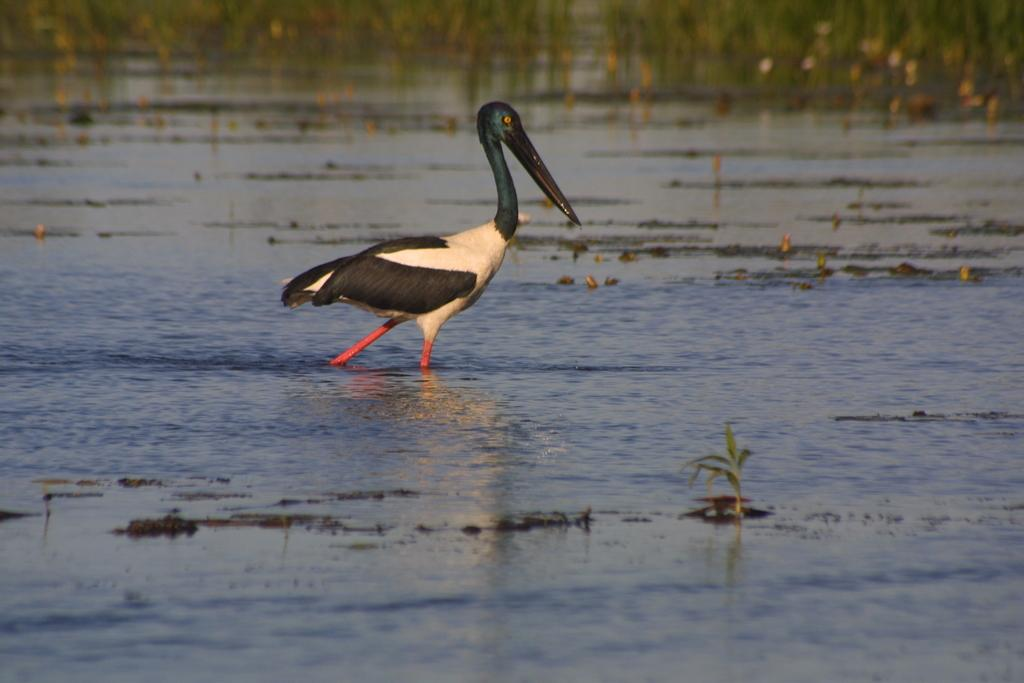What type of animal is in the image? There is a bird in the image. What color is the bird? The bird is in black and white color. What is the bird doing in the image? The bird is walking in water. What can be seen in the background of the image? There are plants in the background of the image. What color are the plants? The plants are green in color. How many eyes does the bird have on its mitten in the image? There is no mitten present in the image, and the bird does not have eyes on a mitten. 